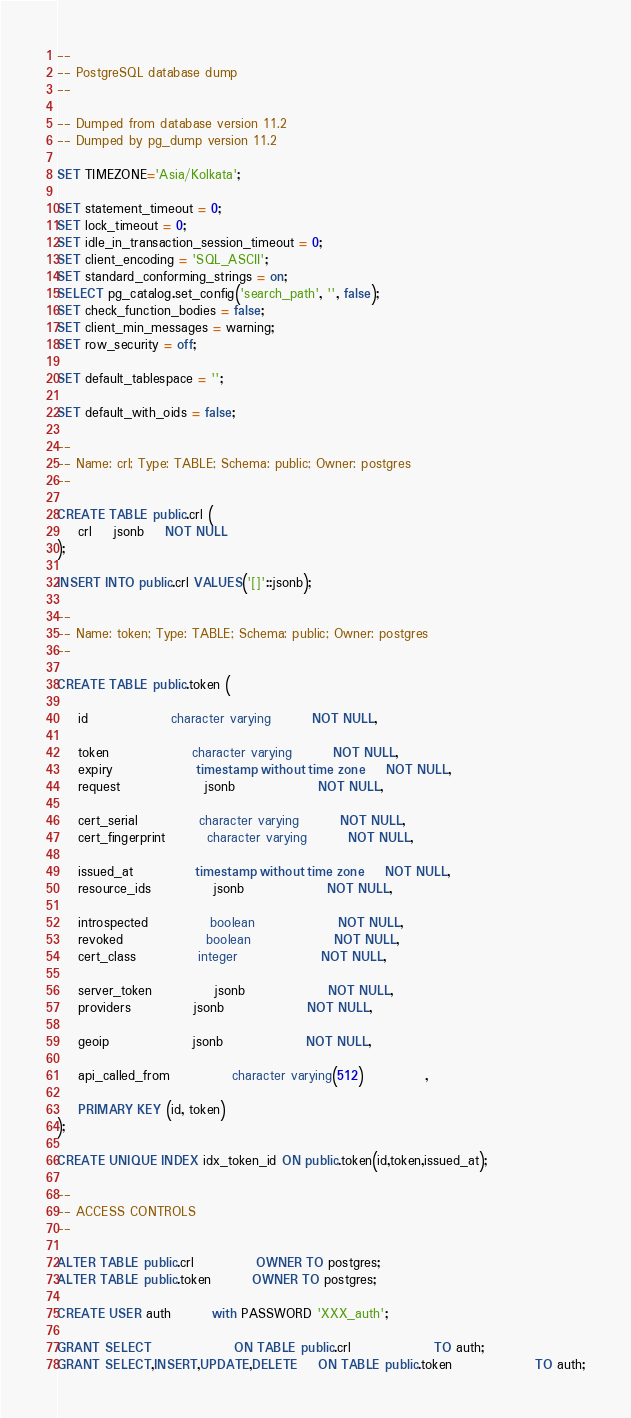<code> <loc_0><loc_0><loc_500><loc_500><_SQL_>--
-- PostgreSQL database dump
--

-- Dumped from database version 11.2
-- Dumped by pg_dump version 11.2

SET TIMEZONE='Asia/Kolkata';

SET statement_timeout = 0;
SET lock_timeout = 0;
SET idle_in_transaction_session_timeout = 0;
SET client_encoding = 'SQL_ASCII';
SET standard_conforming_strings = on;
SELECT pg_catalog.set_config('search_path', '', false);
SET check_function_bodies = false;
SET client_min_messages = warning;
SET row_security = off;

SET default_tablespace = '';

SET default_with_oids = false;

--
-- Name: crl; Type: TABLE; Schema: public; Owner: postgres
--

CREATE TABLE public.crl (
	crl	jsonb	NOT NULL
);

INSERT INTO public.crl VALUES('[]'::jsonb);

--
-- Name: token; Type: TABLE; Schema: public; Owner: postgres
--

CREATE TABLE public.token (

	id				character varying		NOT NULL,

	token				character varying		NOT NULL,
	expiry				timestamp without time zone	NOT NULL,
	request				jsonb				NOT NULL,

	cert_serial			character varying		NOT NULL,
	cert_fingerprint		character varying		NOT NULL,

	issued_at			timestamp without time zone	NOT NULL,
	resource_ids			jsonb				NOT NULL,

	introspected			boolean				NOT NULL,
	revoked				boolean				NOT NULL,
	cert_class			integer				NOT NULL,

	server_token			jsonb				NOT NULL,
	providers			jsonb				NOT NULL,

	geoip				jsonb				NOT NULL,

	api_called_from			character varying(512)			,

	PRIMARY KEY (id, token)
);

CREATE UNIQUE INDEX idx_token_id ON public.token(id,token,issued_at);

--
-- ACCESS CONTROLS
--

ALTER TABLE public.crl			OWNER TO postgres;
ALTER TABLE public.token		OWNER TO postgres;

CREATE USER auth		with PASSWORD 'XXX_auth';

GRANT SELECT				ON TABLE public.crl				TO auth;
GRANT SELECT,INSERT,UPDATE,DELETE	ON TABLE public.token				TO auth;
</code> 